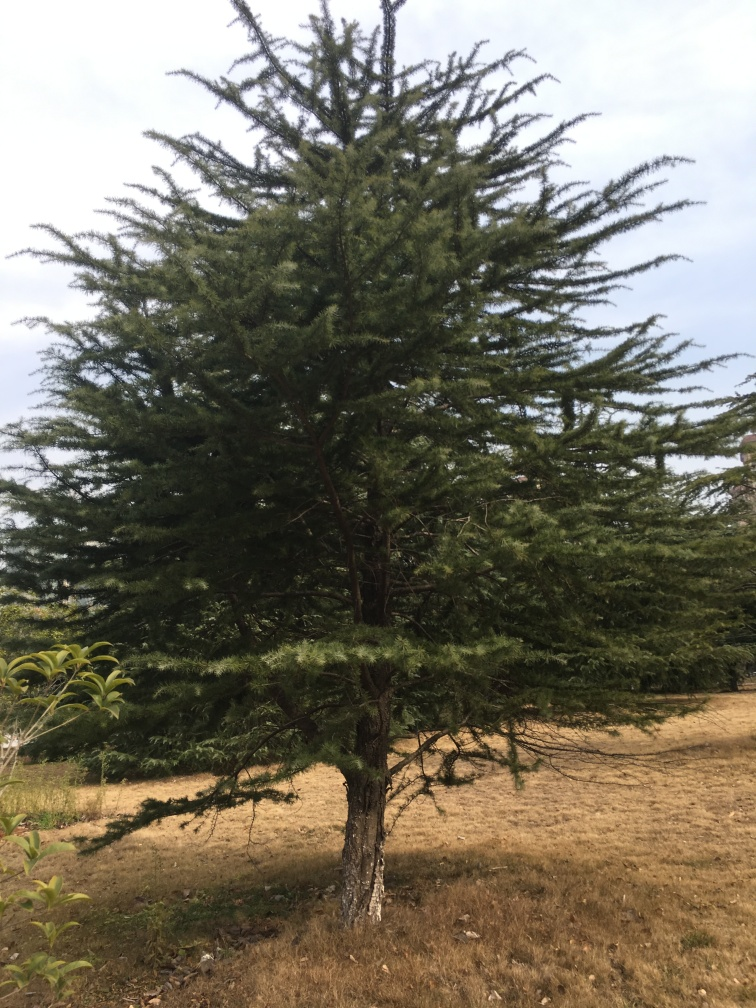What time of year does this photo look like it was taken? Considering the dry, golden-brown grass and the full foliage on the conifer, it suggests a late summer or early autumn timeframe when many regions experience dryer climates, but evergreens like this tree remain lush. 